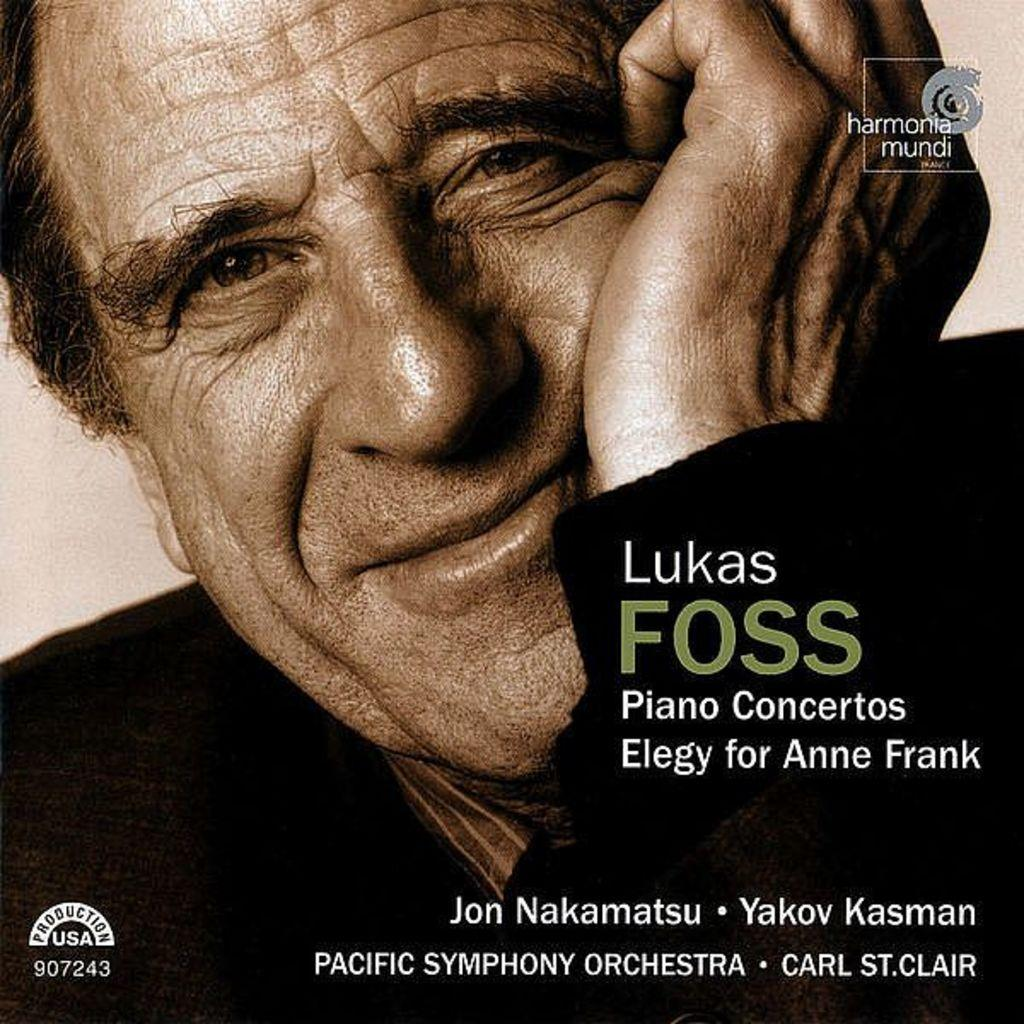What is present in the image that features an image and text? There is a poster in the image that contains an image and text. What type of image is on the poster? The poster contains an image of a man. What can be read on the poster? There is text on the poster. How does the poster contribute to world peace in the image? The poster does not specifically address world peace in the image, as it only contains an image of a man and text. 